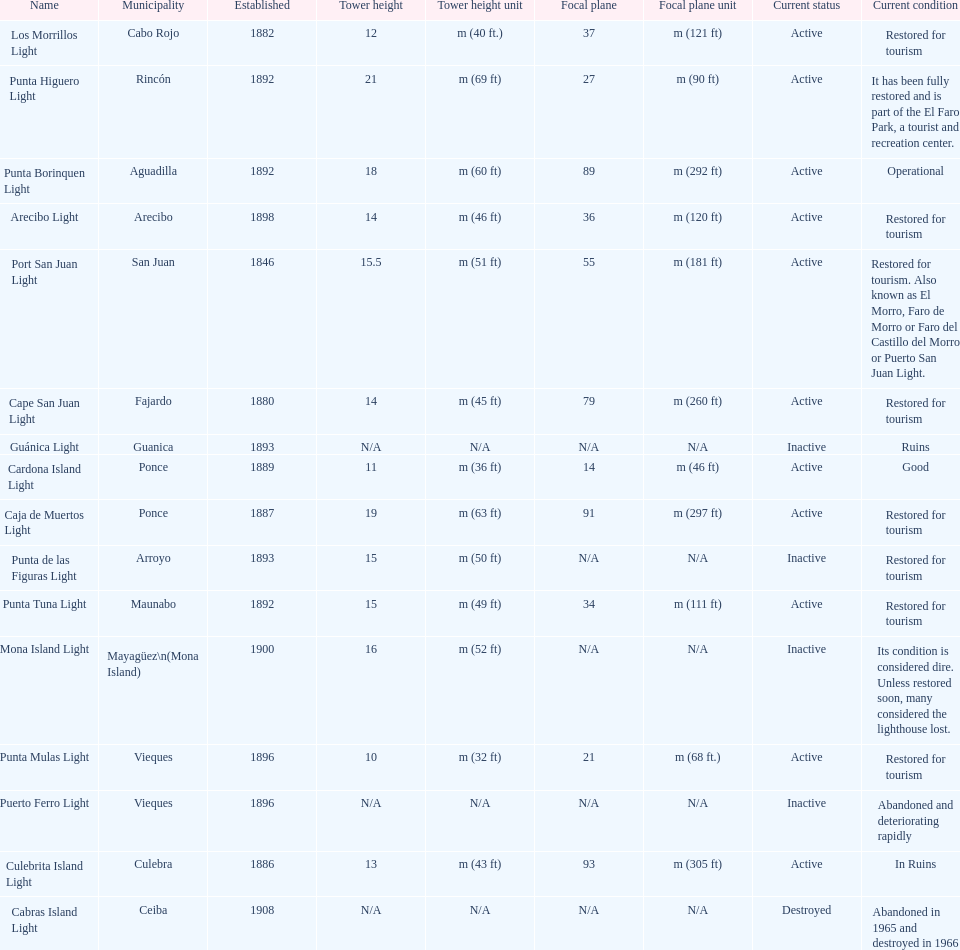Which municipality was the first to be established? San Juan. 